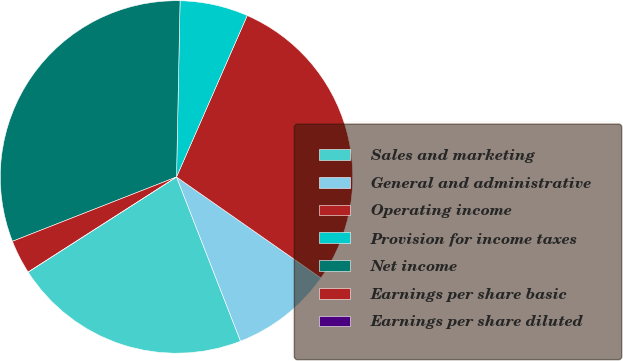Convert chart. <chart><loc_0><loc_0><loc_500><loc_500><pie_chart><fcel>Sales and marketing<fcel>General and administrative<fcel>Operating income<fcel>Provision for income taxes<fcel>Net income<fcel>Earnings per share basic<fcel>Earnings per share diluted<nl><fcel>21.85%<fcel>9.37%<fcel>28.14%<fcel>6.25%<fcel>31.27%<fcel>3.12%<fcel>0.0%<nl></chart> 